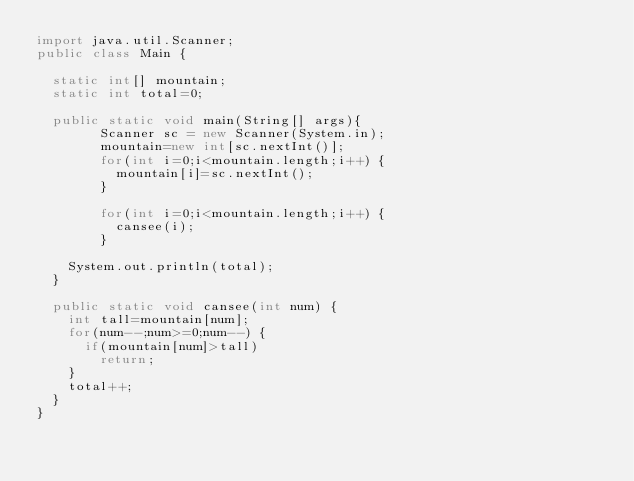<code> <loc_0><loc_0><loc_500><loc_500><_Java_>import java.util.Scanner;
public class Main {

	static int[] mountain;
	static int total=0;

	public static void main(String[] args){
      	Scanner sc = new Scanner(System.in);
      	mountain=new int[sc.nextInt()];
      	for(int i=0;i<mountain.length;i++) {
      		mountain[i]=sc.nextInt();
      	}

      	for(int i=0;i<mountain.length;i++) {
      		cansee(i);
      	}

		System.out.println(total);
	}

	public static void cansee(int num) {
		int tall=mountain[num];
		for(num--;num>=0;num--) {
			if(mountain[num]>tall)
				return;
		}
		total++;
	}
}</code> 